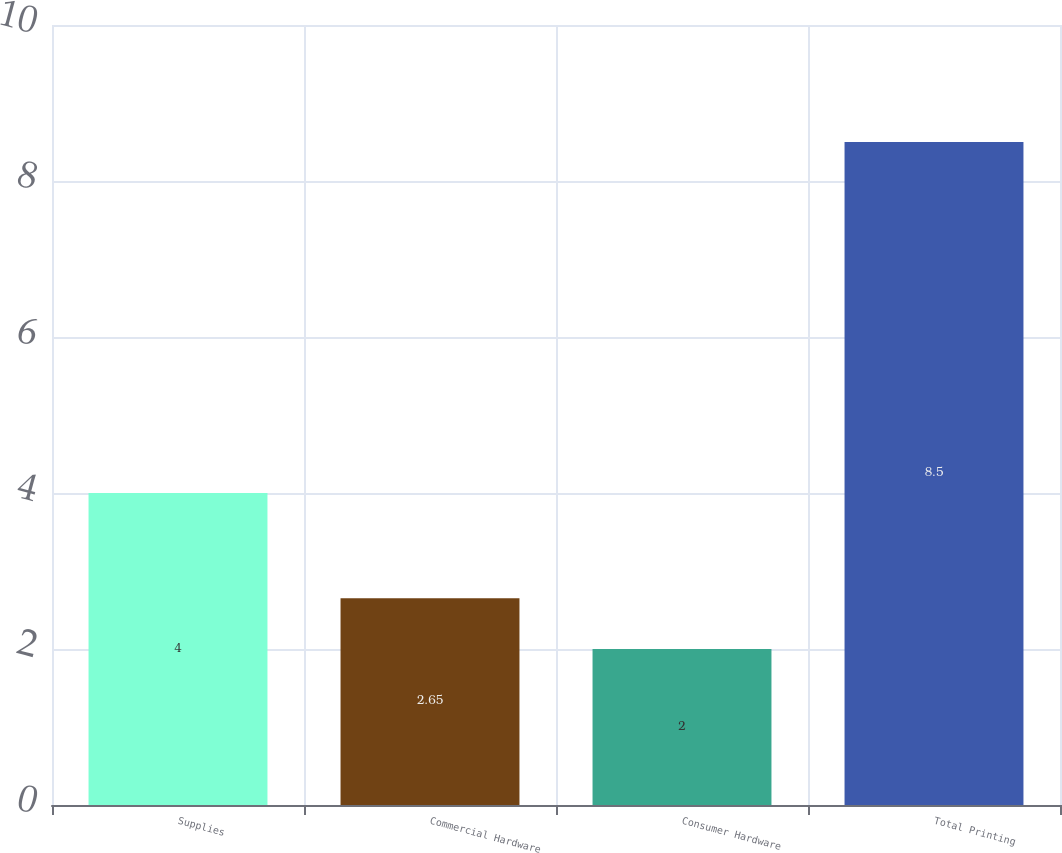Convert chart to OTSL. <chart><loc_0><loc_0><loc_500><loc_500><bar_chart><fcel>Supplies<fcel>Commercial Hardware<fcel>Consumer Hardware<fcel>Total Printing<nl><fcel>4<fcel>2.65<fcel>2<fcel>8.5<nl></chart> 